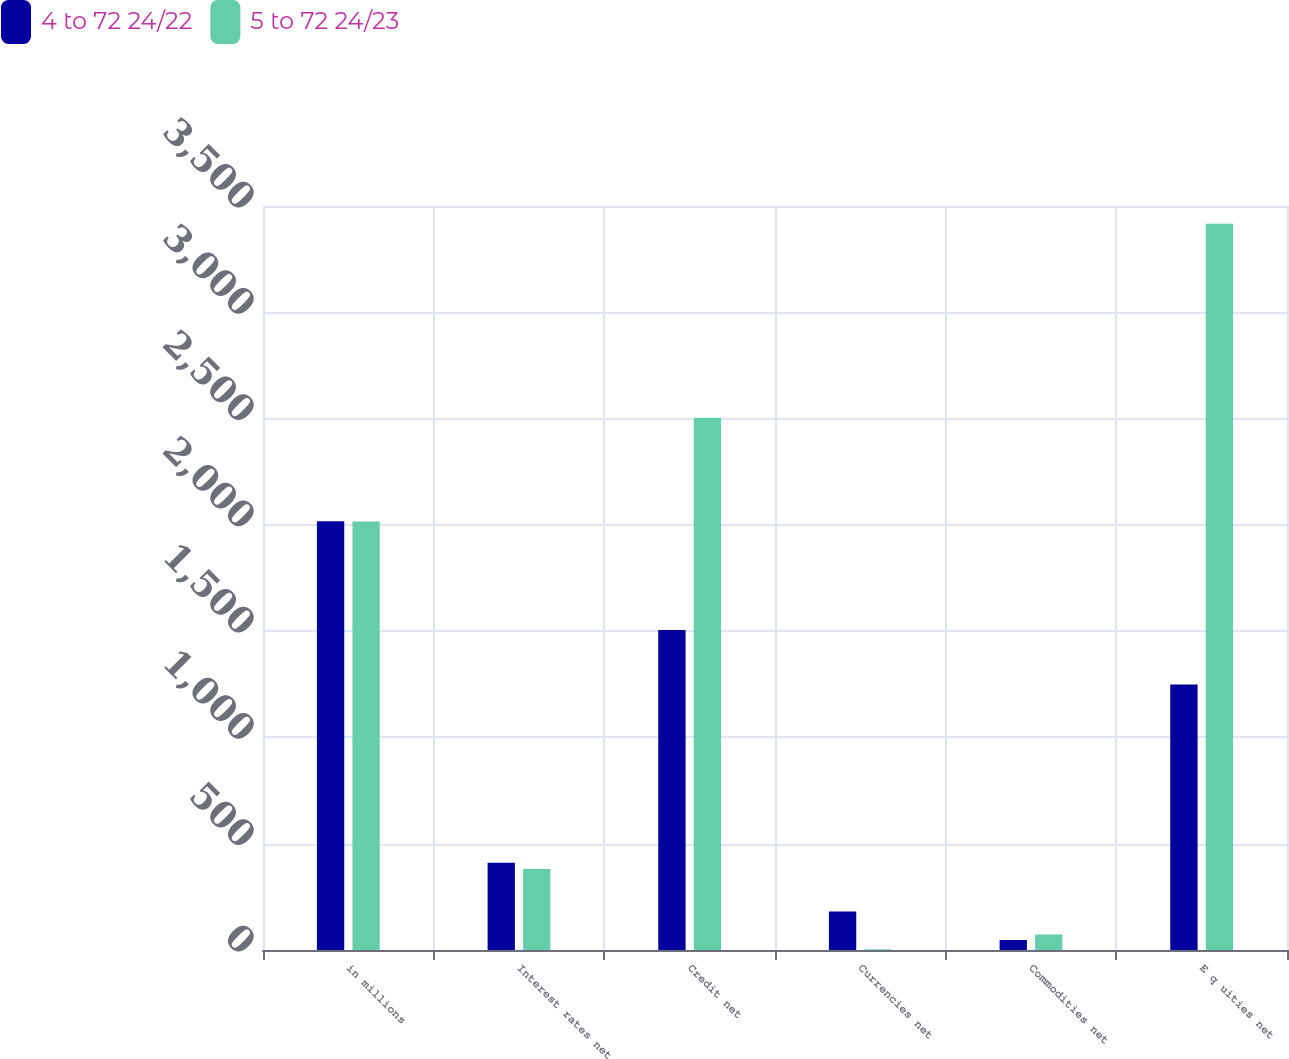Convert chart to OTSL. <chart><loc_0><loc_0><loc_500><loc_500><stacked_bar_chart><ecel><fcel>in millions<fcel>Interest rates net<fcel>Credit net<fcel>Currencies net<fcel>Commodities net<fcel>E q uities net<nl><fcel>4 to 72 24/22<fcel>2017<fcel>410<fcel>1505<fcel>181<fcel>47<fcel>1249<nl><fcel>5 to 72 24/23<fcel>2016<fcel>381<fcel>2504<fcel>3<fcel>73<fcel>3416<nl></chart> 